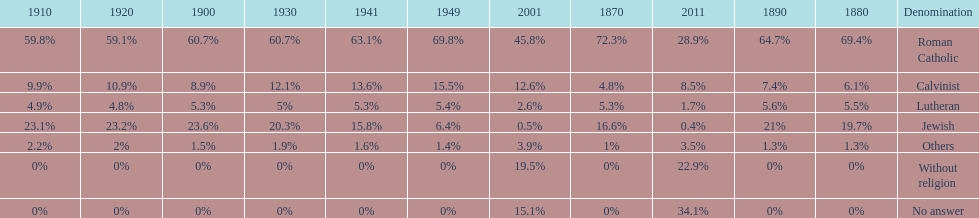The percentage of people who identified as calvinist was, at most, how much? 15.5%. 